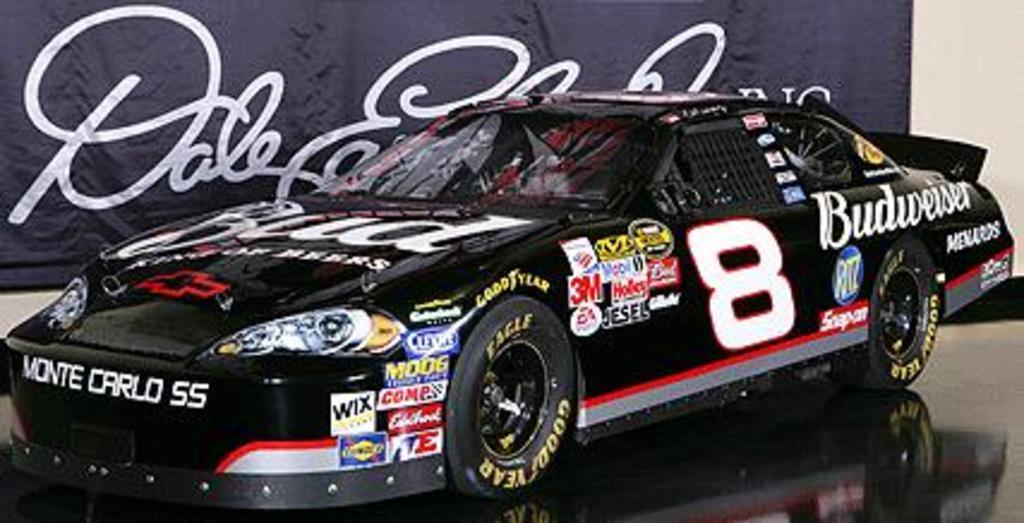How would you summarize this image in a sentence or two? This image is taken indoors. At the bottom of the image there is a floor. In the background there is a banner with a text on it and there is a wall. In the middle of the image a car is parked on the floor. 